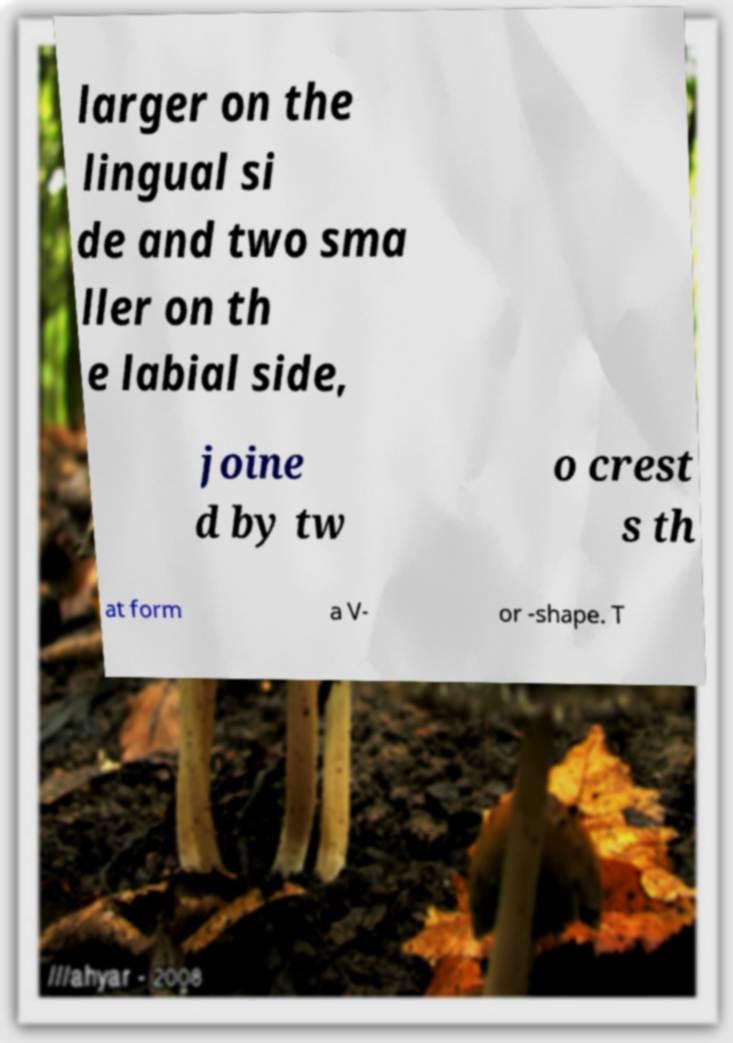I need the written content from this picture converted into text. Can you do that? larger on the lingual si de and two sma ller on th e labial side, joine d by tw o crest s th at form a V- or -shape. T 